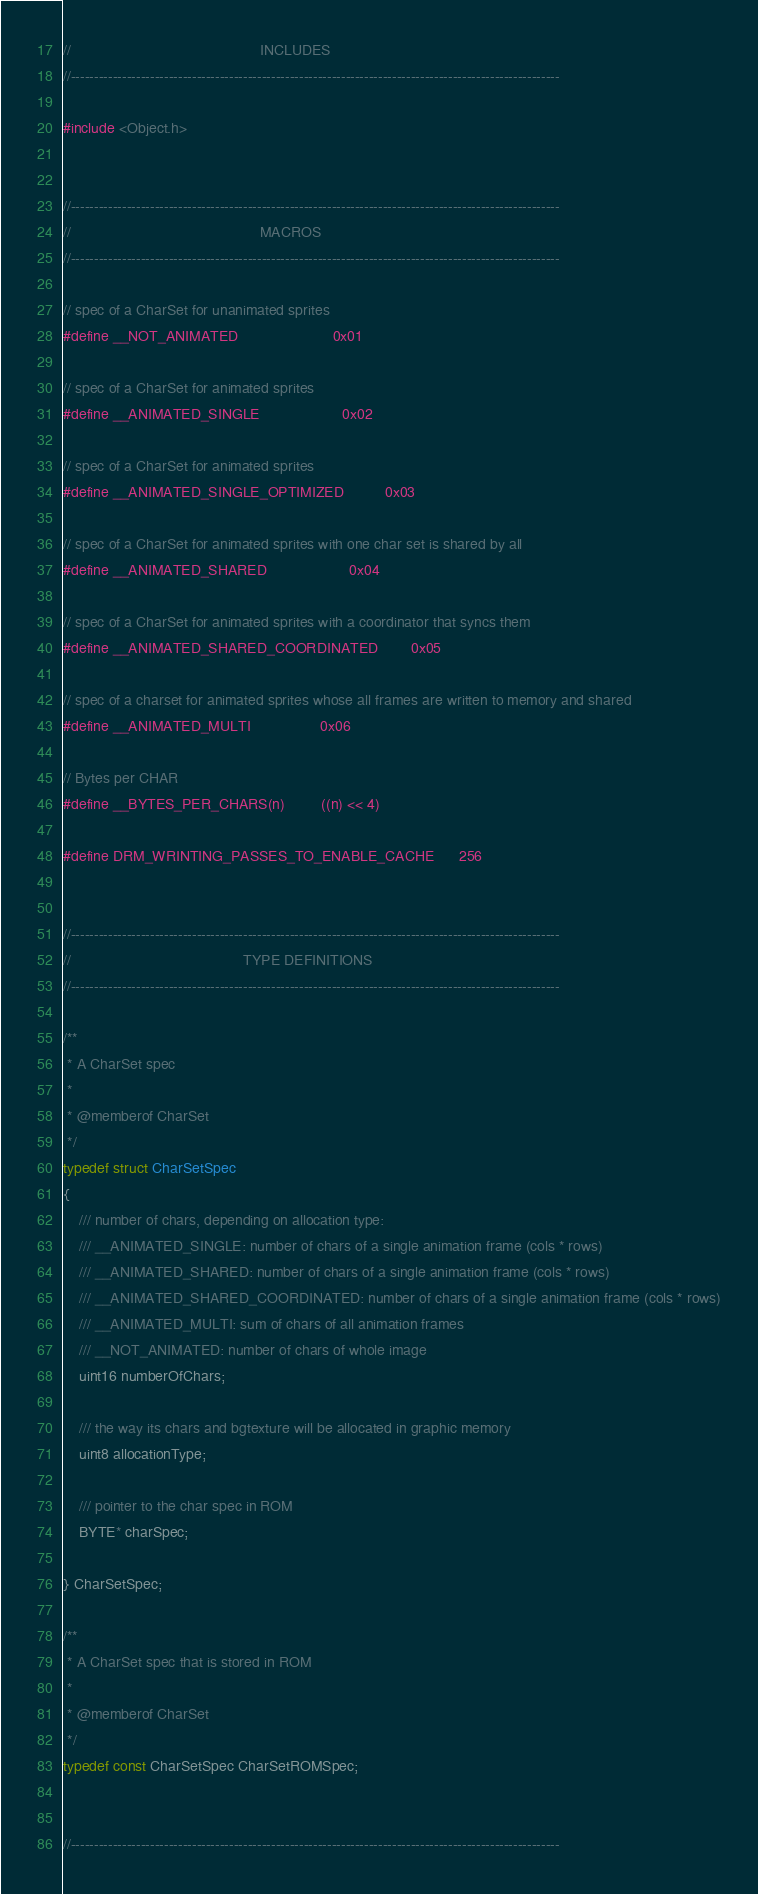Convert code to text. <code><loc_0><loc_0><loc_500><loc_500><_C_>//												INCLUDES
//---------------------------------------------------------------------------------------------------------

#include <Object.h>


//---------------------------------------------------------------------------------------------------------
//												MACROS
//---------------------------------------------------------------------------------------------------------

// spec of a CharSet for unanimated sprites
#define __NOT_ANIMATED						0x01

// spec of a CharSet for animated sprites
#define __ANIMATED_SINGLE					0x02

// spec of a CharSet for animated sprites
#define __ANIMATED_SINGLE_OPTIMIZED			0x03

// spec of a CharSet for animated sprites with one char set is shared by all
#define __ANIMATED_SHARED					0x04

// spec of a CharSet for animated sprites with a coordinator that syncs them
#define __ANIMATED_SHARED_COORDINATED		0x05

// spec of a charset for animated sprites whose all frames are written to memory and shared
#define __ANIMATED_MULTI					0x06

// Bytes per CHAR
#define __BYTES_PER_CHARS(n)			((n) << 4)

#define DRM_WRINTING_PASSES_TO_ENABLE_CACHE		256


//---------------------------------------------------------------------------------------------------------
//											TYPE DEFINITIONS
//---------------------------------------------------------------------------------------------------------

/**
 * A CharSet spec
 *
 * @memberof CharSet
 */
typedef struct CharSetSpec
{
	/// number of chars, depending on allocation type:
	/// __ANIMATED_SINGLE: number of chars of a single animation frame (cols * rows)
	/// __ANIMATED_SHARED: number of chars of a single animation frame (cols * rows)
	/// __ANIMATED_SHARED_COORDINATED: number of chars of a single animation frame (cols * rows)
	/// __ANIMATED_MULTI: sum of chars of all animation frames
	/// __NOT_ANIMATED: number of chars of whole image
	uint16 numberOfChars;

	/// the way its chars and bgtexture will be allocated in graphic memory
	uint8 allocationType;

	/// pointer to the char spec in ROM
	BYTE* charSpec;

} CharSetSpec;

/**
 * A CharSet spec that is stored in ROM
 *
 * @memberof CharSet
 */
typedef const CharSetSpec CharSetROMSpec;


//---------------------------------------------------------------------------------------------------------</code> 